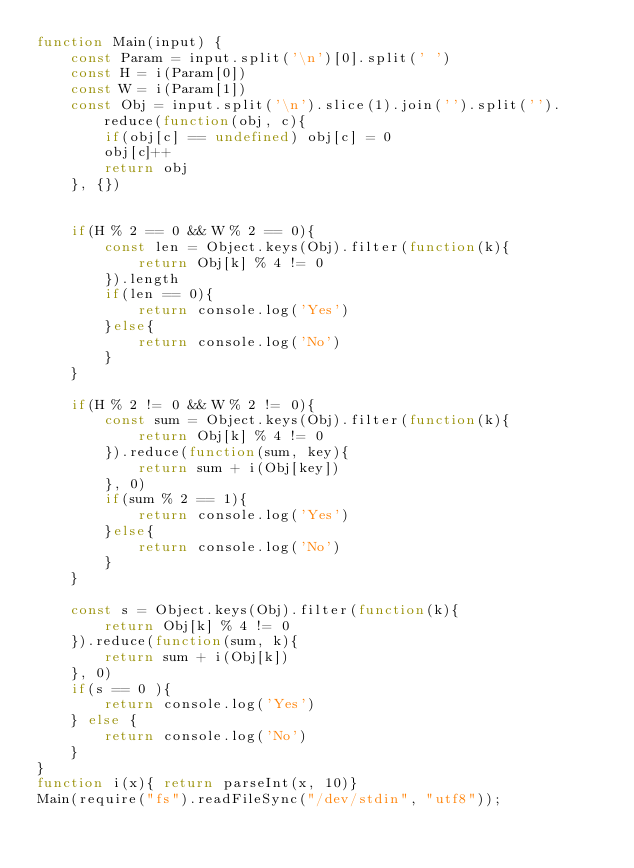<code> <loc_0><loc_0><loc_500><loc_500><_JavaScript_>function Main(input) {
    const Param = input.split('\n')[0].split(' ')
    const H = i(Param[0])
    const W = i(Param[1])
    const Obj = input.split('\n').slice(1).join('').split('').reduce(function(obj, c){
        if(obj[c] == undefined) obj[c] = 0
        obj[c]++
        return obj
    }, {})


    if(H % 2 == 0 && W % 2 == 0){
        const len = Object.keys(Obj).filter(function(k){
            return Obj[k] % 4 != 0
        }).length
        if(len == 0){
            return console.log('Yes')
        }else{
            return console.log('No')
        }
    }

    if(H % 2 != 0 && W % 2 != 0){
        const sum = Object.keys(Obj).filter(function(k){
            return Obj[k] % 4 != 0
        }).reduce(function(sum, key){
            return sum + i(Obj[key])
        }, 0)
        if(sum % 2 == 1){
            return console.log('Yes')
        }else{
            return console.log('No')
        }
    }

    const s = Object.keys(Obj).filter(function(k){
        return Obj[k] % 4 != 0
    }).reduce(function(sum, k){
        return sum + i(Obj[k])
    }, 0)
    if(s == 0 ){
        return console.log('Yes')
    } else {
        return console.log('No')
    }
}
function i(x){ return parseInt(x, 10)}
Main(require("fs").readFileSync("/dev/stdin", "utf8"));</code> 